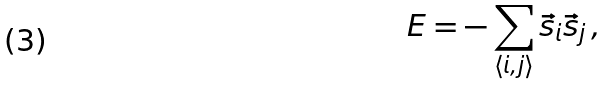Convert formula to latex. <formula><loc_0><loc_0><loc_500><loc_500>E = - \sum _ { \langle i , j \rangle } { \vec { s } _ { i } \vec { s } _ { j } } \, ,</formula> 